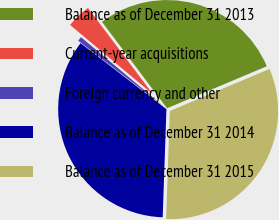Convert chart to OTSL. <chart><loc_0><loc_0><loc_500><loc_500><pie_chart><fcel>Balance as of December 31 2013<fcel>Current-year acquisitions<fcel>Foreign currency and other<fcel>Balance as of December 31 2014<fcel>Balance as of December 31 2015<nl><fcel>28.92%<fcel>3.64%<fcel>0.66%<fcel>34.88%<fcel>31.9%<nl></chart> 